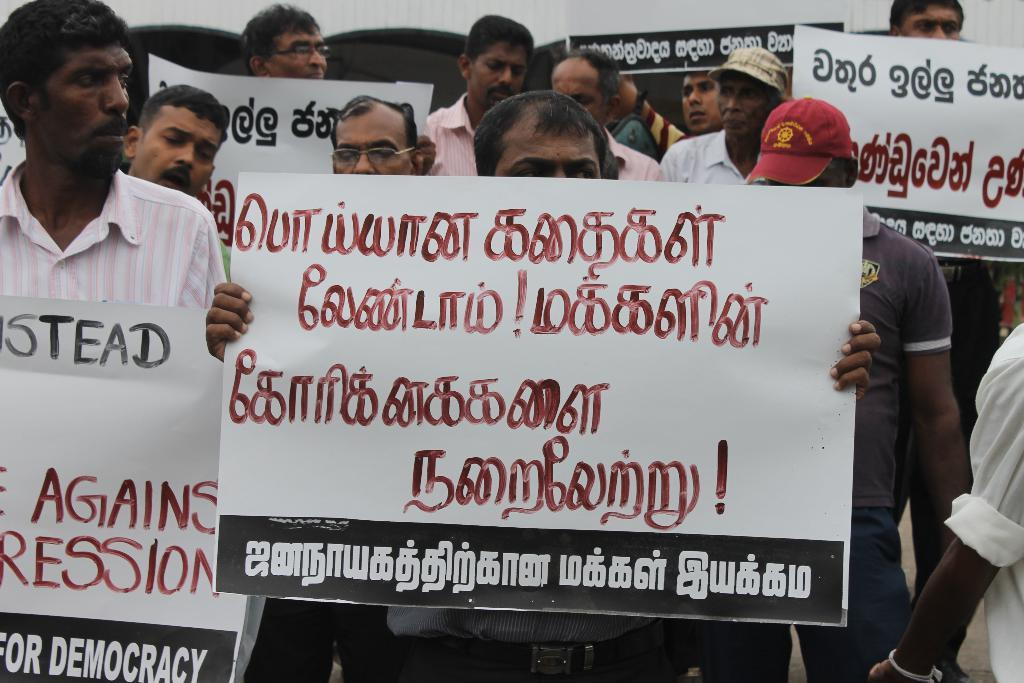How many men are present in the image? There are many men in the image. What are the men doing in the image? The men are standing in the image. What objects are the men holding in the image? The men are holding banners in the image. What type of produce can be seen being ordered by the men in the image? There is no produce present in the image, nor is there any indication of the men ordering anything. How many planes are visible in the image? There are no planes visible in the image. 